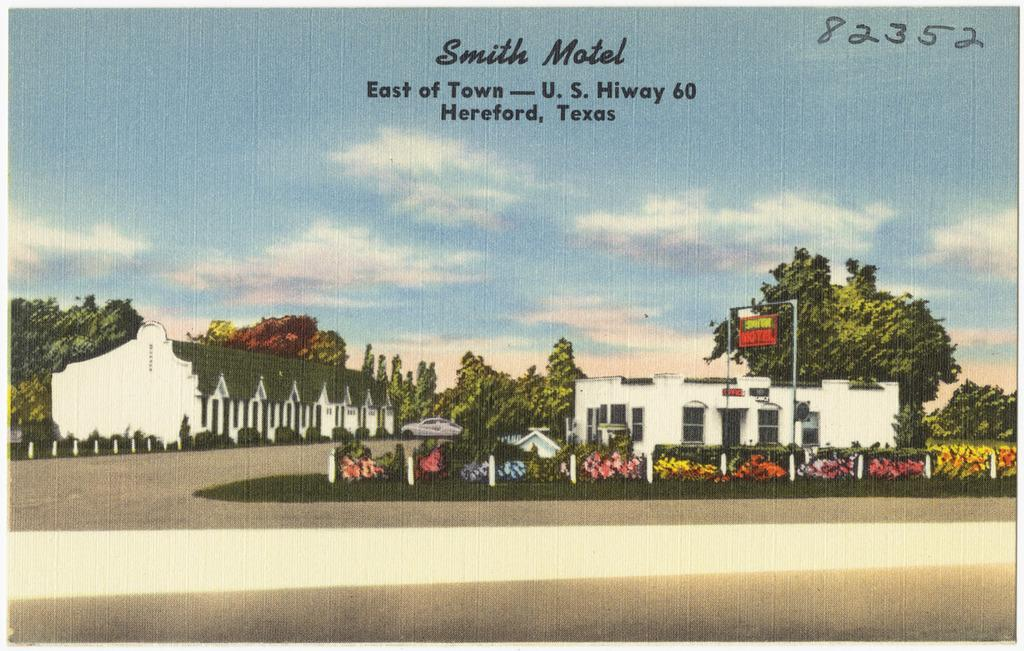What type of surface can be seen in the image? There is a road in the image. What other natural elements are present in the image? There are plants and trees in the image. What man-made structures can be seen in the image? There are houses and a board in the image. What is visible in the background of the image? There are trees, a car, and the sky in the background of the image. What is written or displayed at the top of the image? There is text at the top of the image. Can you see a mountain in the image? No, there is no mountain present in the image. Is there a trail visible in the image? No, there is no trail visible in the image. 